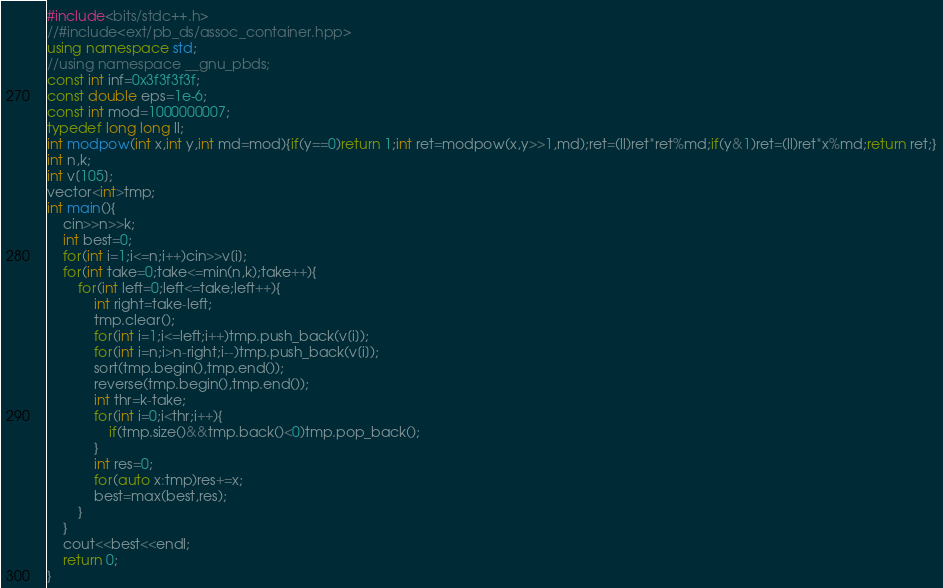Convert code to text. <code><loc_0><loc_0><loc_500><loc_500><_C++_>#include<bits/stdc++.h>
//#include<ext/pb_ds/assoc_container.hpp>
using namespace std;
//using namespace __gnu_pbds;
const int inf=0x3f3f3f3f;
const double eps=1e-6;
const int mod=1000000007;
typedef long long ll;
int modpow(int x,int y,int md=mod){if(y==0)return 1;int ret=modpow(x,y>>1,md);ret=(ll)ret*ret%md;if(y&1)ret=(ll)ret*x%md;return ret;}
int n,k;
int v[105];
vector<int>tmp;
int main(){
	cin>>n>>k;
	int best=0;
	for(int i=1;i<=n;i++)cin>>v[i];
	for(int take=0;take<=min(n,k);take++){
		for(int left=0;left<=take;left++){
			int right=take-left;
			tmp.clear();
			for(int i=1;i<=left;i++)tmp.push_back(v[i]);
			for(int i=n;i>n-right;i--)tmp.push_back(v[i]);
			sort(tmp.begin(),tmp.end());
			reverse(tmp.begin(),tmp.end());
			int thr=k-take;
			for(int i=0;i<thr;i++){
				if(tmp.size()&&tmp.back()<0)tmp.pop_back();
			}
			int res=0;
			for(auto x:tmp)res+=x;
			best=max(best,res);
		}
	}
	cout<<best<<endl;
	return 0;
}</code> 